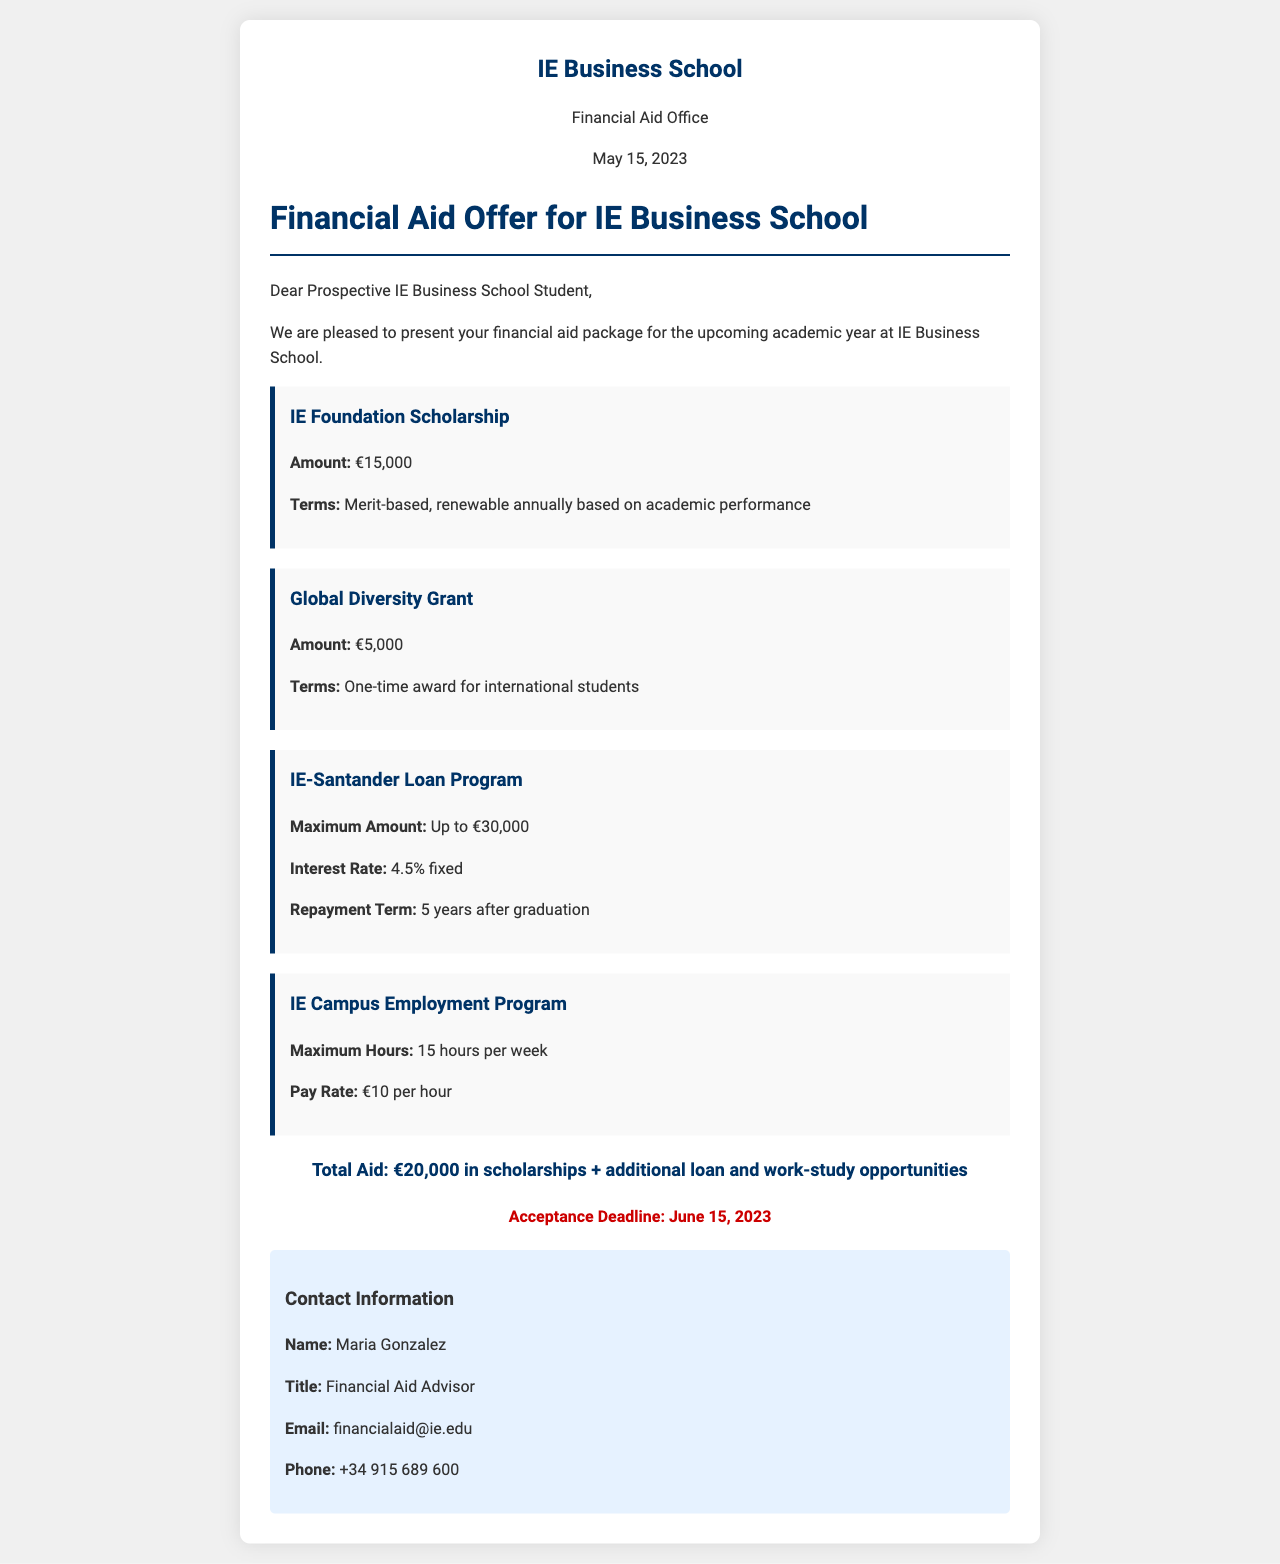What is the scholarship amount for the IE Foundation Scholarship? The scholarship amount is specified in the document as €15,000 for the IE Foundation Scholarship.
Answer: €15,000 What are the terms of the Global Diversity Grant? The terms indicate that the Global Diversity Grant is a one-time award for international students.
Answer: One-time award for international students What is the maximum amount available for the IE-Santander Loan Program? The maximum amount for the loan program is mentioned in the document as €30,000.
Answer: Up to €30,000 Who is the Financial Aid Advisor listed in the document? The document specifies that Maria Gonzalez is the Financial Aid Advisor.
Answer: Maria Gonzalez What is the acceptance deadline for the financial aid offer? The acceptance deadline is clearly stated in the document as June 15, 2023.
Answer: June 15, 2023 How much can a student earn through the IE Campus Employment Program? The pay rate mentioned in the document for the employment program is €10 per hour.
Answer: €10 per hour What is the interest rate for the IE-Santander Loan Program? The interest rate is specified as a fixed rate of 4.5%.
Answer: 4.5% What is the total aid amount listed in the document? The total aid amount includes €20,000 in scholarships plus other opportunities.
Answer: €20,000 in scholarships How many hours per week can a student work in the IE Campus Employment Program? The document states that a student can work a maximum of 15 hours per week.
Answer: 15 hours per week 